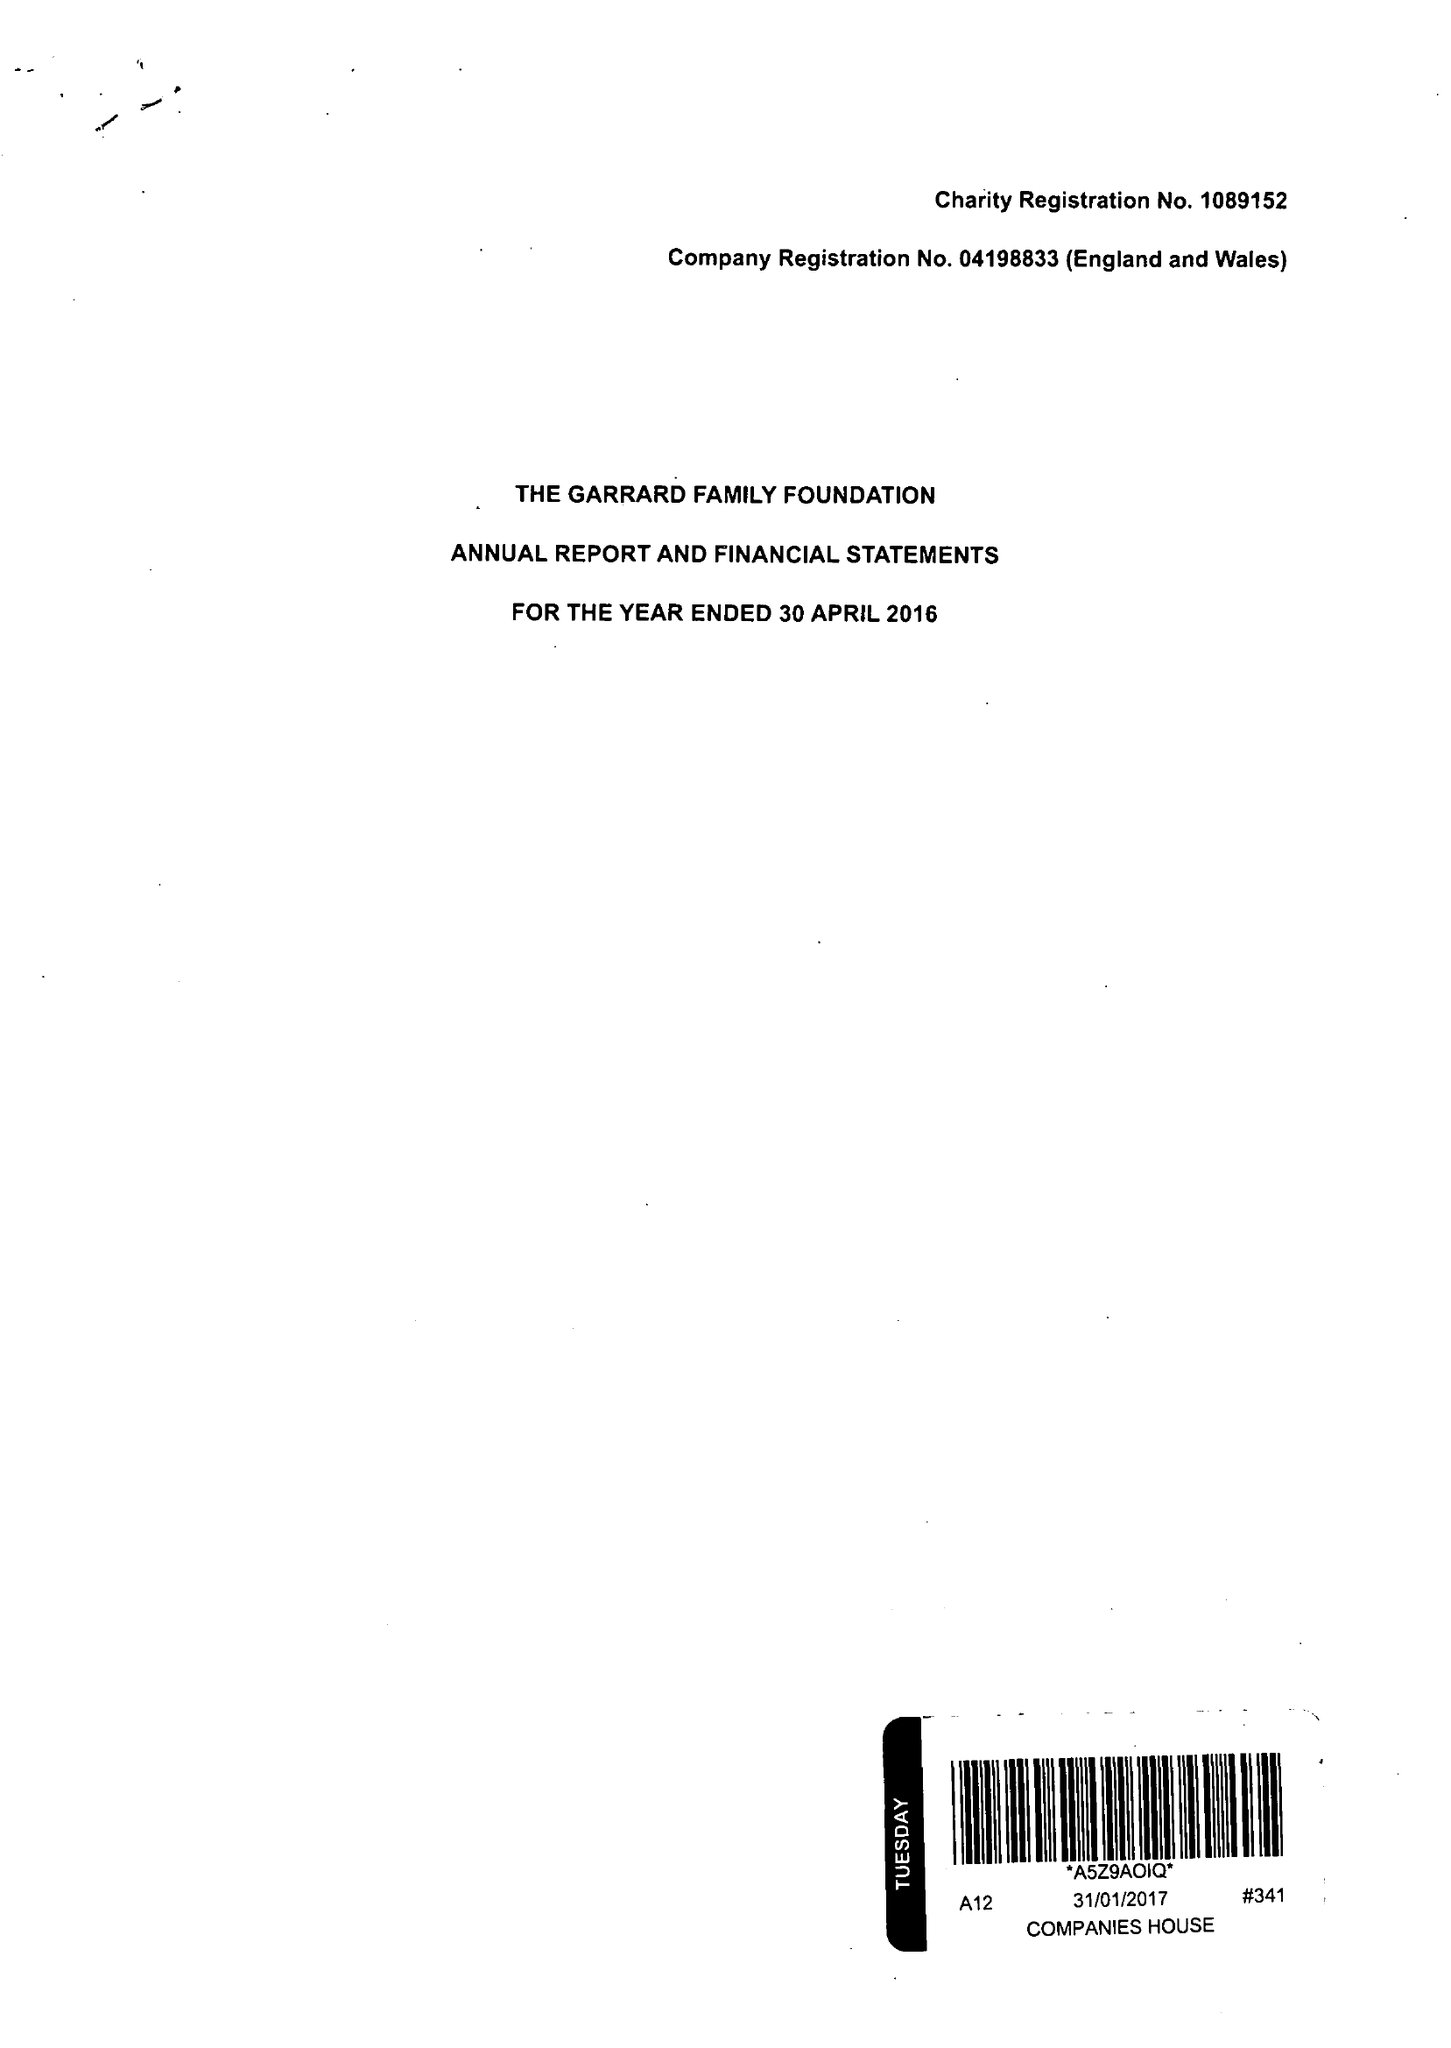What is the value for the report_date?
Answer the question using a single word or phrase. 2016-04-30 